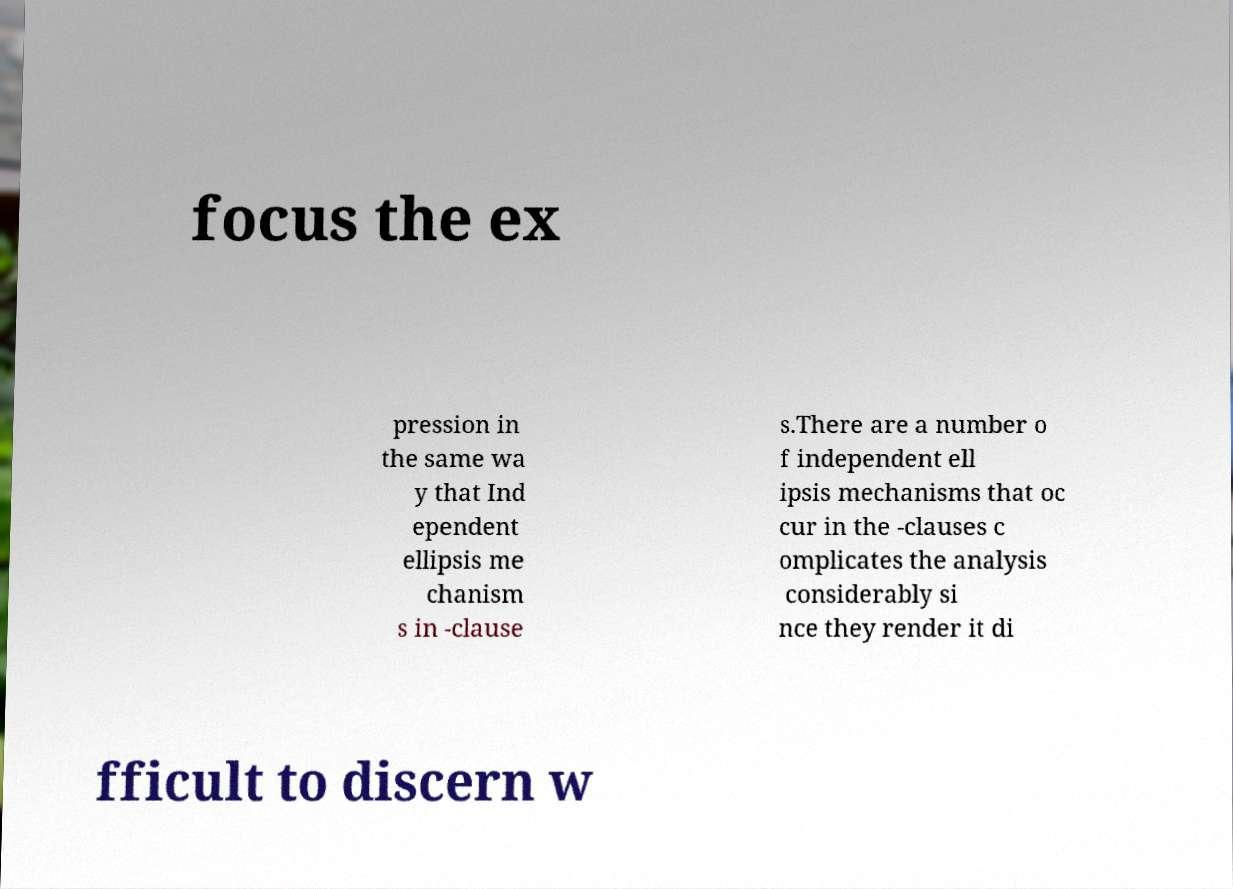Can you read and provide the text displayed in the image?This photo seems to have some interesting text. Can you extract and type it out for me? focus the ex pression in the same wa y that Ind ependent ellipsis me chanism s in -clause s.There are a number o f independent ell ipsis mechanisms that oc cur in the -clauses c omplicates the analysis considerably si nce they render it di fficult to discern w 